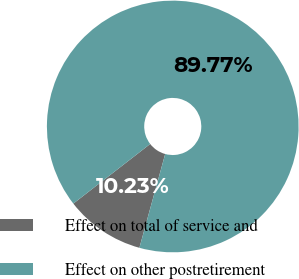<chart> <loc_0><loc_0><loc_500><loc_500><pie_chart><fcel>Effect on total of service and<fcel>Effect on other postretirement<nl><fcel>10.23%<fcel>89.77%<nl></chart> 